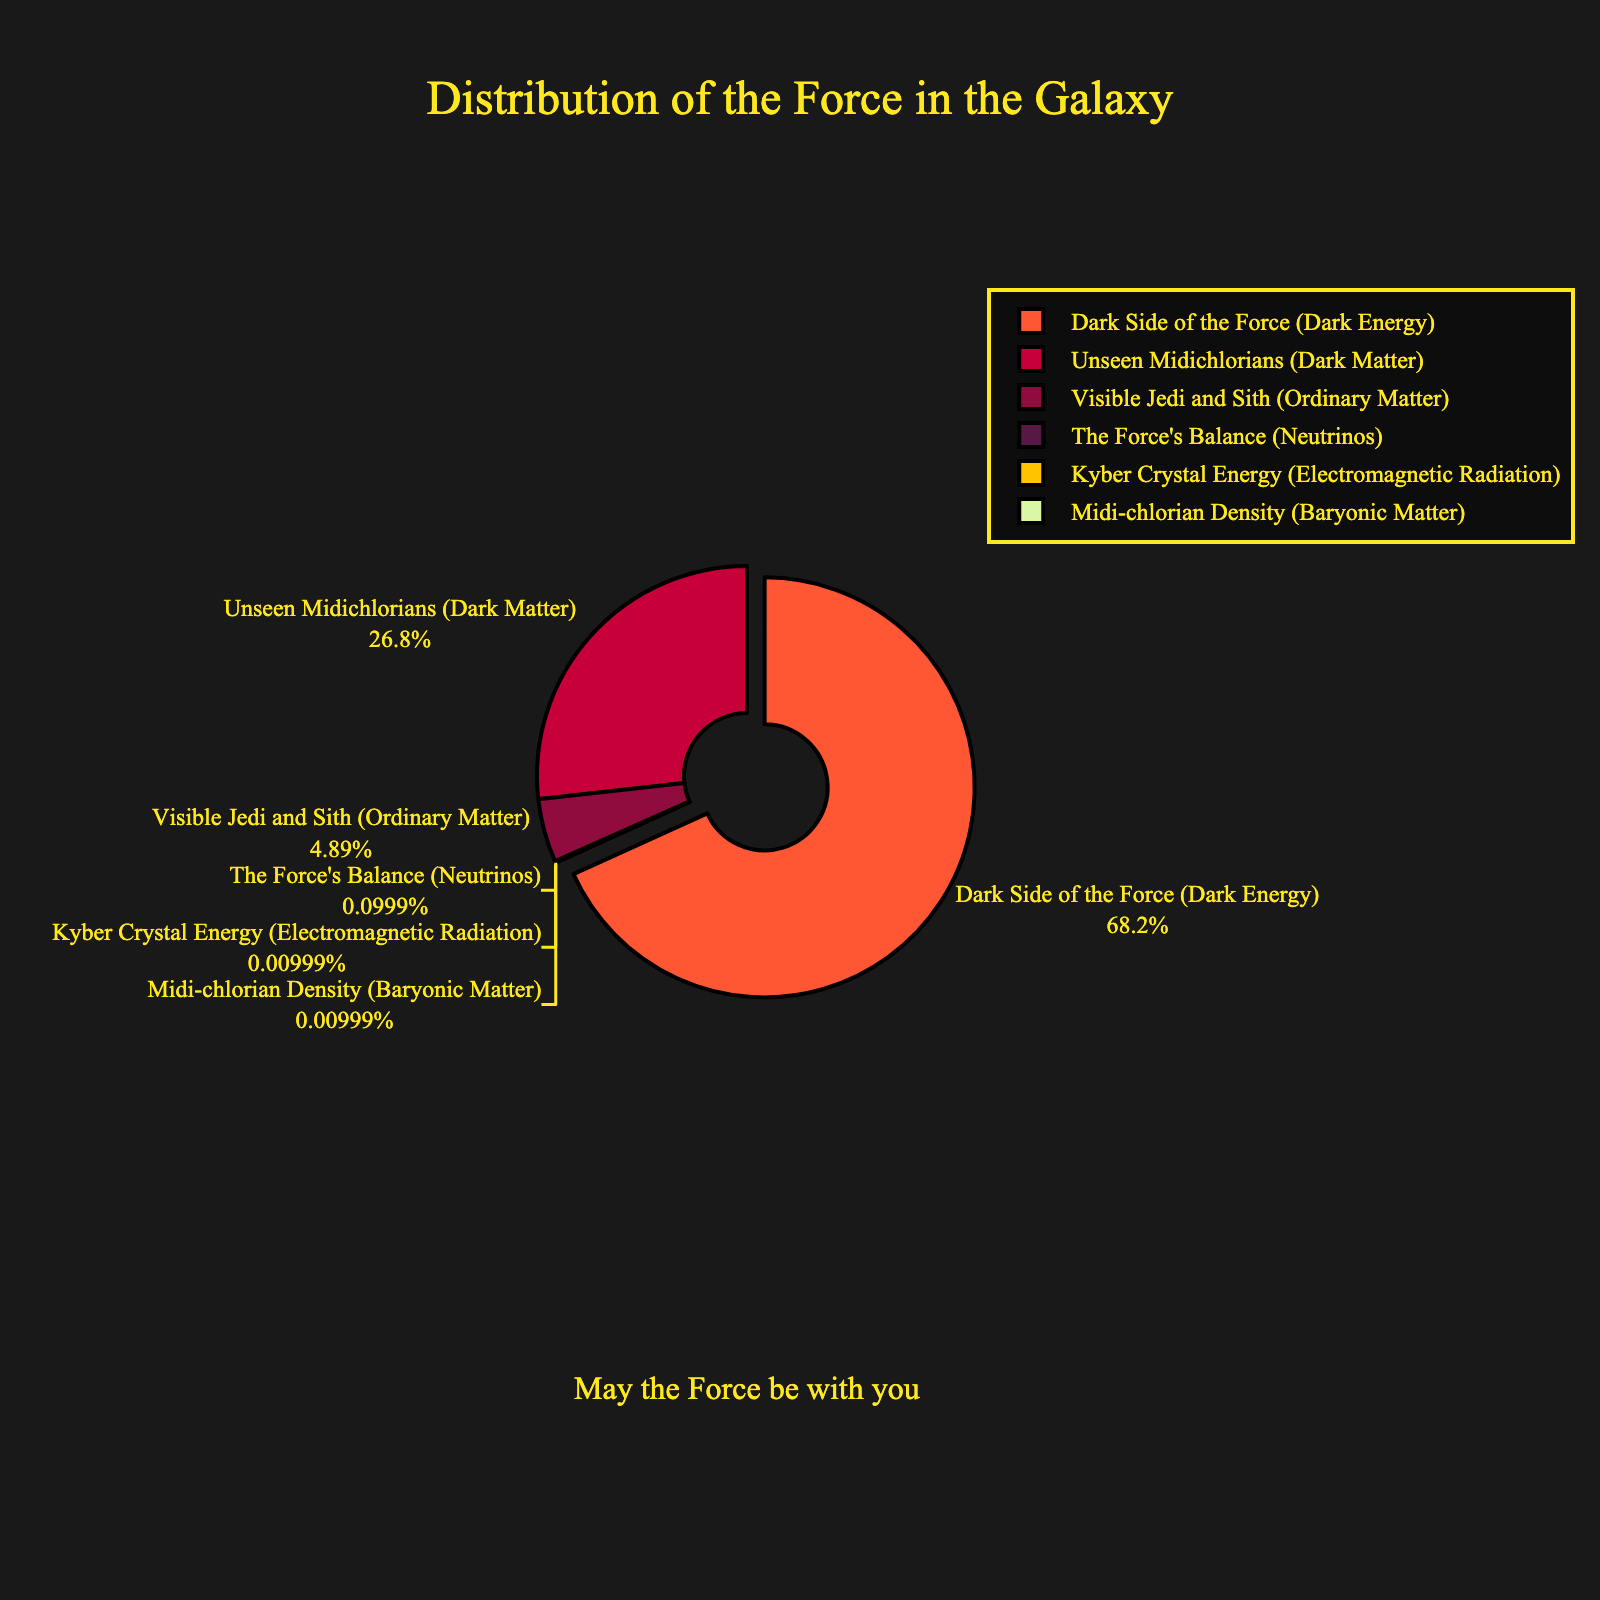Which component of the Force has the largest visual representation in the pie chart? The largest visual representation is given to "Dark Side of the Force (Dark Energy)" which is represented by the largest section in the pie chart.
Answer: Dark Side of the Force (Dark Energy) Which Force component has the smallest percentage and is pulled slightly outwards for emphasis? The section labeled "Dark Side of the Force (Dark Energy)" is slightly pulled out from the pie chart, indicating it as a significant part.
Answer: Dark Side of the Force (Dark Energy) What is the total percentage for components other than the Dark Side of the Force and Unseen Midichlorians? To find this, sum the percentages of "Visible Jedi and Sith," "The Force's Balance," "Kyber Crystal Energy," and "Midi-chlorian Density": 4.9 + <0.1 + <0.01 + 0.01 = ~5%.
Answer: ~5% Compare the proportions of the Dark Side of the Force to Unseen Midichlorians. Which is larger and by how much? The Dark Side of the Force (68.3%) is larger than Unseen Midichlorians (26.8%). The difference is 68.3 - 26.8 = 41.5%.
Answer: Dark Side of the Force by 41.5% If we combine all components related to visible matter (Visible Jedi and Sith, Kyber Crystal Energy, Midi-chlorian Density), what is the total percentage? Summing up Visible Jedi and Sith (4.9%), Kyber Crystal Energy (<0.01%), and Midi-chlorian Density (0.01%), we get approximately 4.9 + <0.01 + 0.01 = ~5%.
Answer: ~5% Which visual attribute of the pie chart emphasizes the total percentage of the Dark Side of the Force? The section representing the "Dark Side of the Force (Dark Energy)" is emphasized by being pulled slightly outwards and having a distinct color.
Answer: Pulled outwards, distinct color Compare the percentages of The Force's Balance and Visible Jedi and Sith. How many times larger is the Visible Jedi and Sith component? The percentage of Visible Jedi and Sith is 4.9%, while The Force's Balance is <0.1%. To find how many times larger, 4.9 / 0.1 = 49 times larger.
Answer: 49 times larger Which Force component occupies the smallest visual segment after the pulled-out section? After the "Dark Side of the Force (Dark Energy)" which is slightly pulled out, the smallest visual segment is for "Kyber Crystal Energy".
Answer: Kyber Crystal Energy What percentage of the Force is made up of all components except for the two largest (Dark Side of the Force and Unseen Midichlorians)? Summing all the remaining components: 4.9% (Visible Jedi and Sith) + <0.1% (The Force's Balance) + <0.01% (Kyber Crystal Energy) + 0.01% (Midi-chlorian Density) = ~5%.
Answer: ~5% What is the color scheme used for the Force component labeled "Unseen Midichlorians"? Observing the pie chart, "Unseen Midichlorians (Dark Matter)" is represented by a distinct color among the custom color scheme. The exact name is not used in the visual description, but it can be identified as one of the unique colors.
Answer: Unique color 